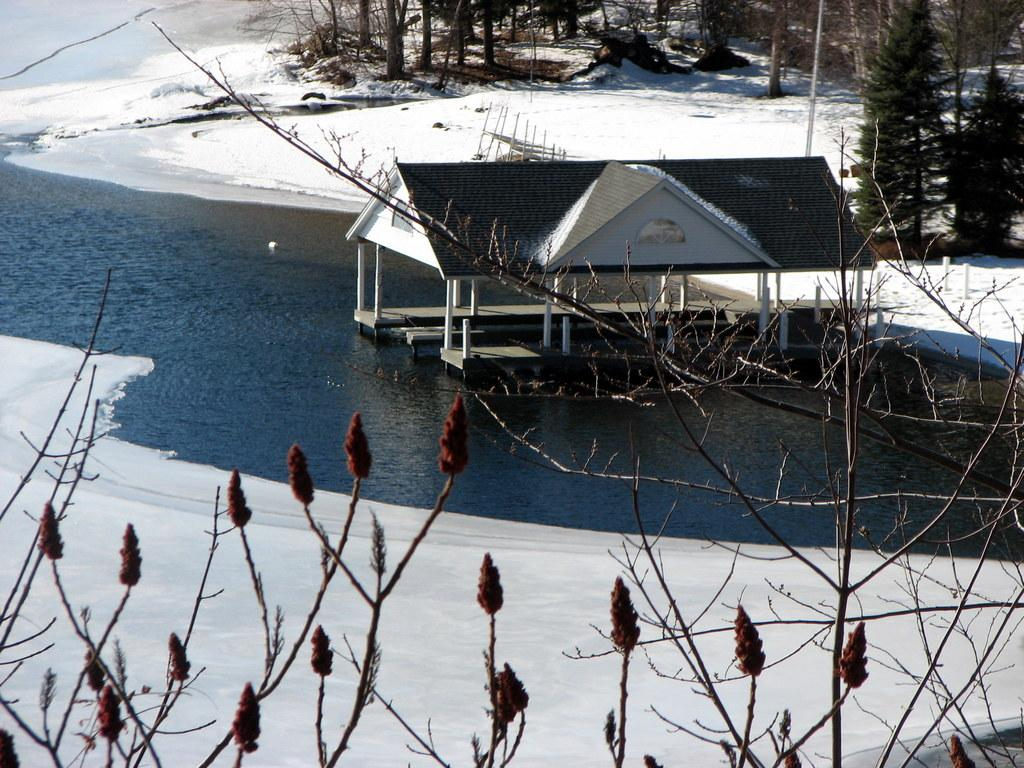What type of vegetation can be seen in the image? There are plants and trees in the image. What is the body of water in the image called? There is a watershed in the image. Is there any ice visible in the image? Yes, there is ice in the image. Can you determine the time of day the image was taken? The image was likely taken during the day, as there is no indication of darkness or artificial lighting. What type of surprise is hidden in the image? There is no surprise hidden in the image; it simply depicts plants, trees, a watershed, and ice. What type of meal is being prepared in the image? There is no meal preparation visible in the image; it only shows natural elements such as plants, trees, a watershed, and ice. 